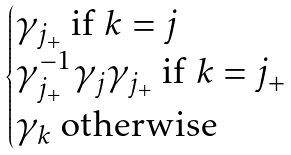Convert formula to latex. <formula><loc_0><loc_0><loc_500><loc_500>\begin{cases} \gamma _ { j _ { + } } \text { if } k = j \\ \gamma _ { j _ { + } } ^ { - 1 } \gamma _ { j } \gamma _ { j _ { + } } \text { if } k = j _ { + } \\ \gamma _ { k } \text { otherwise } \end{cases}</formula> 